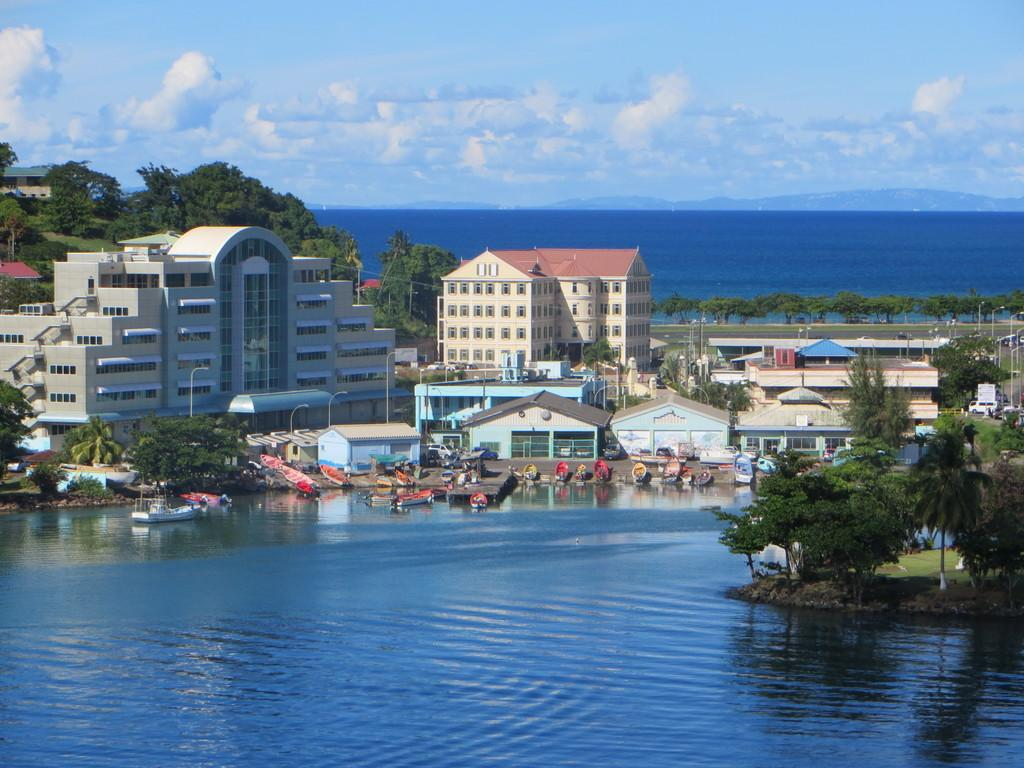What types of structures can be seen in the image? There are buildings, houses, and boats in the image. What other natural elements are present in the image? There are trees and water visible in the image. What man-made structures can be seen in the image? There are poles and a road in the image. What can be seen in the background of the image? In the background, there are hills and the sky is visible. How many pins are holding the boats in place in the image? There are no pins visible in the image; the boats are likely floating on the water. What type of screw is used to secure the poles in the image? There is no screw visible in the image; the poles are likely secured by other means. 